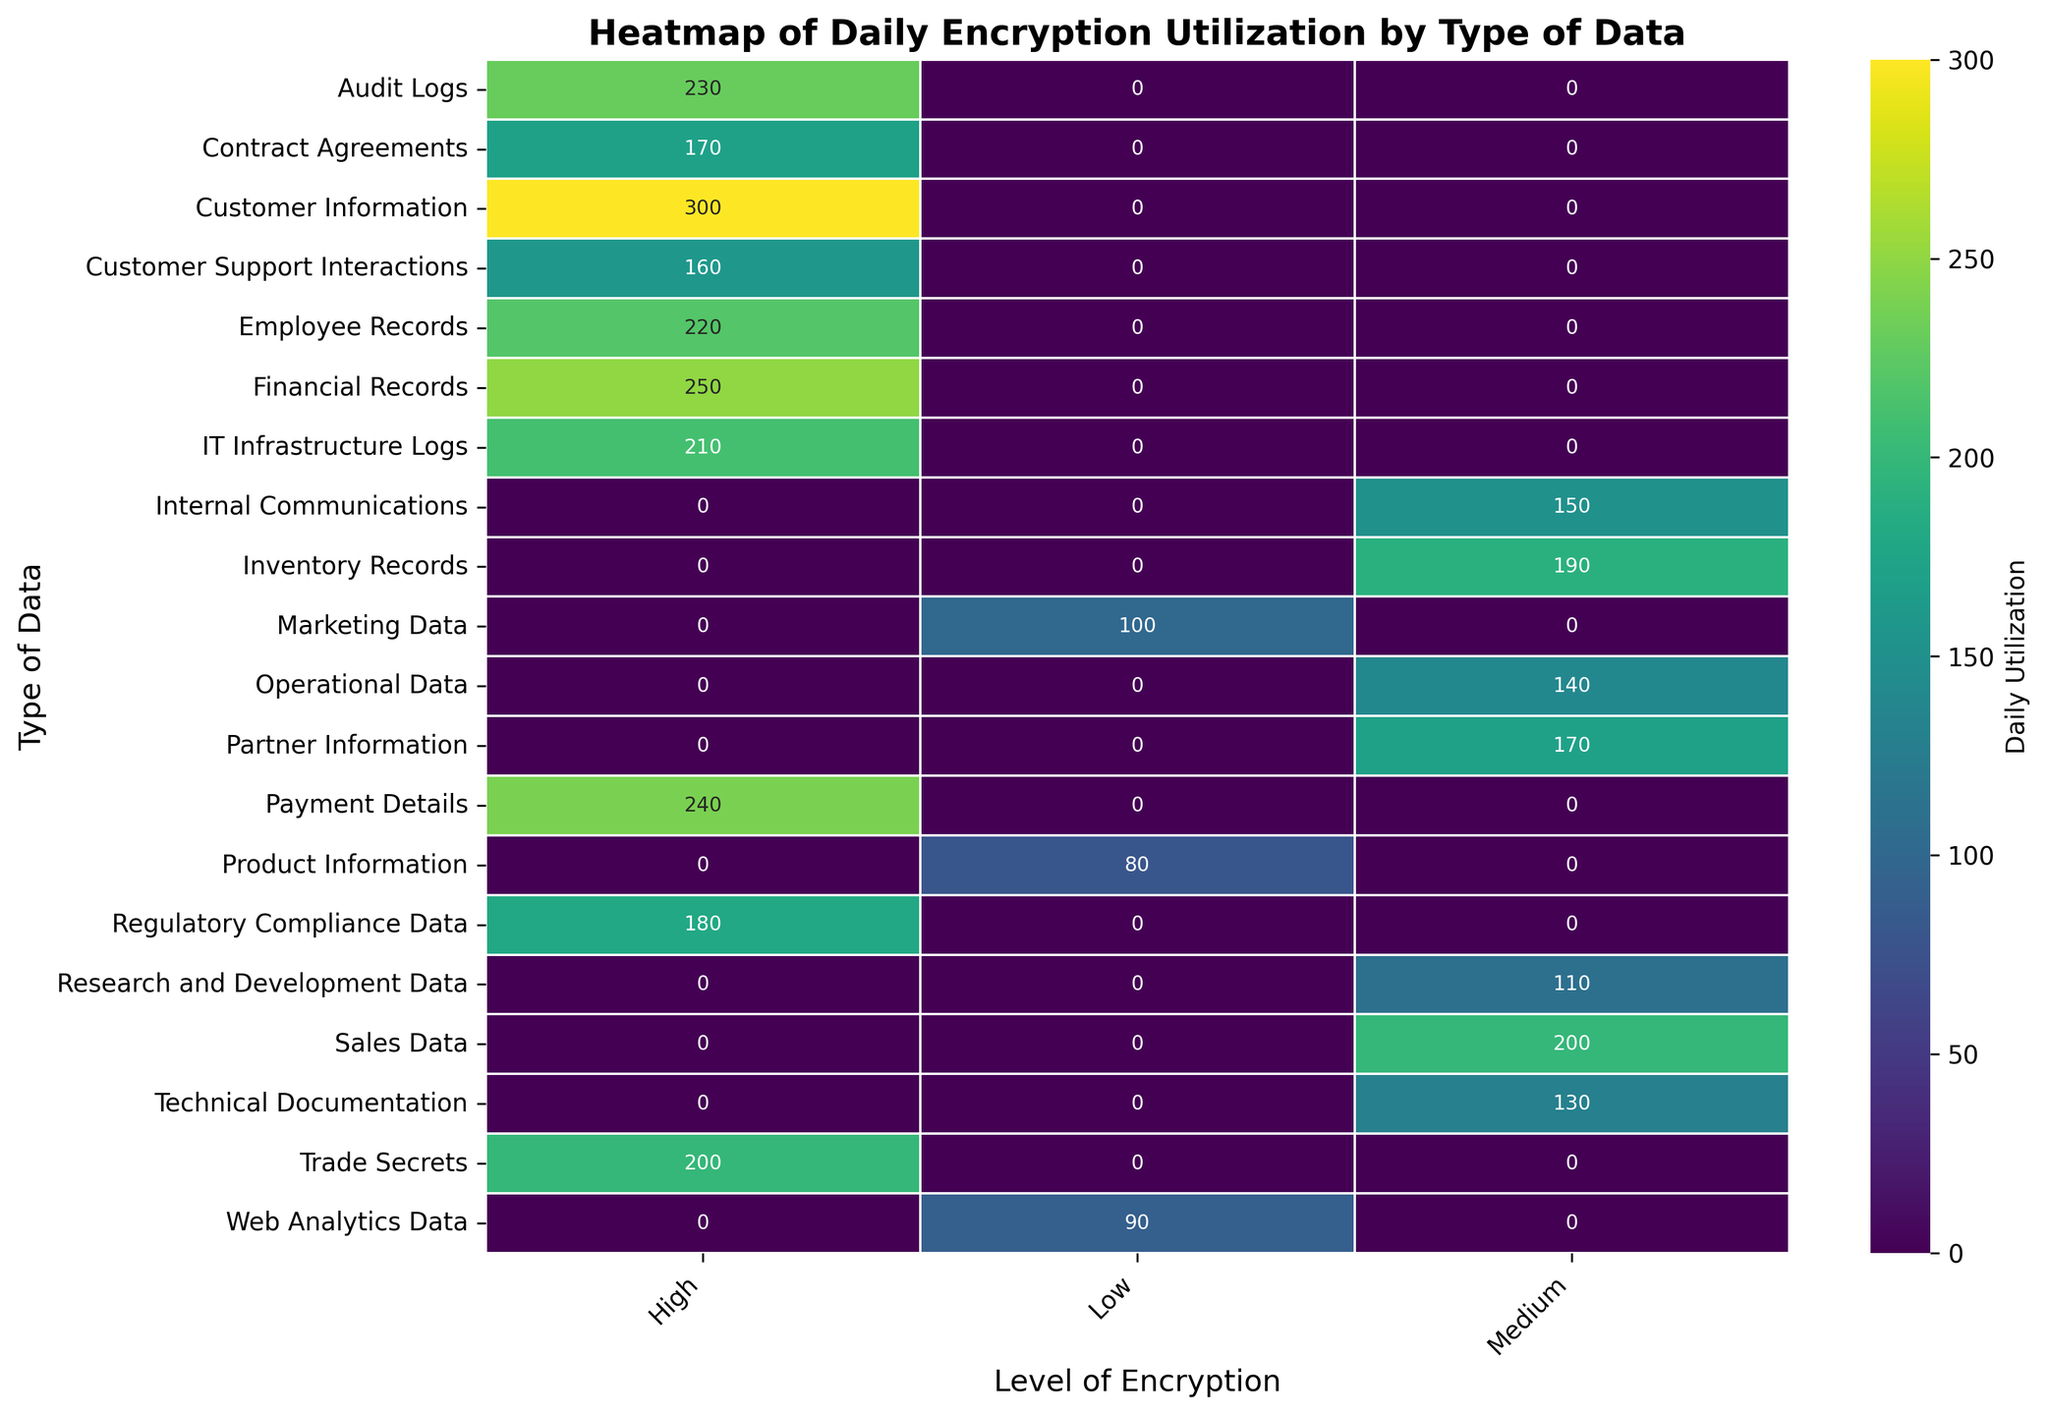What type of data has the highest daily utilization with a high level of encryption? First, filter for data types with a 'High' level of encryption. Then, compare their daily utilization values: Customer Information (300), Financial Records (250), Employee Records (220), Regulatory Compliance Data (180), Customer Support Interactions (160), IT Infrastructure Logs (210), Audit Logs (230), Payment Details (240), Contract Agreements (170), and Trade Secrets (200). Customer Information has the highest utilization at 300.
Answer: Customer Information Which type of data has the lowest daily utilization with a low level of encryption? First, identify the data types with a 'Low' level of encryption: Marketing Data (100), Product Information (80), and Web Analytics Data (90). Compare their daily utilizations and find that Product Information has the lowest at 80.
Answer: Product Information What is the average daily utilization of data types with a medium level of encryption? First, identify the data types with a 'Medium' level of encryption: Internal Communications (150), Sales Data (200), Technical Documentation (130), Partner Information (170), R&D Data (110), Operational Data (140), Inventory Records (190). Sum these utilizations: 150 + 200 + 130 + 170 + 110 + 140 + 190 = 1090. There are 7 data types, so divide 1090 by 7: 1090 / 7 ≈ 155.71
Answer: ~155.71 Compare the daily utilizations of Financial Records and Payment Details. Which one is higher? Inspect the daily utilization values for both Financial Records and Payment Details: Financial Records (250) and Payment Details (240). Since 250 > 240, Financial Records has higher daily utilization.
Answer: Financial Records Is the average daily utilization of data types with high levels of encryption higher than those with medium levels of encryption? First, calculate the average daily utilization for data types with a 'High' level of encryption: (300 + 250 + 220 + 180 + 210 + 230 + 240 + 170 + 200) / 9 = 2000 / 9 ≈ 222.22. For 'Medium' level: (150 + 200 + 130 + 170 + 110 + 140 + 190) / 7 = 1090 / 7 ≈ 155.71. Compare the averages: 222.22 > 155.71, so the average for high encryption is higher.
Answer: Yes Which type of data with a medium level of encryption has the highest daily utilization? Identify the data types with 'Medium' encryption and their daily utilizations: Internal Communications (150), Sales Data (200), Technical Documentation (130), Partner Information (170), R&D Data (110), Operational Data (140), Inventory Records (190). Compare them and find that Sales Data has the highest utilization at 200.
Answer: Sales Data What is the difference in daily utilization between the highest and lowest utilized data types in the dataset? Identify the highest and lowest daily utilizations: Customer Information (300) and Product Information (80). Calculate the difference: 300 - 80 = 220.
Answer: 220 Does 'Internal Communications' have higher or lower daily utilization than 'Customer Support Interactions'? Compare their daily utilization values: Internal Communications (150) and Customer Support Interactions (160). Since 150 < 160, Internal Communications has lower daily utilization.
Answer: Lower Which data types have a daily utilization of exactly 200? Identify data types with exactly 200 daily utilization: Sales Data and Trade Secrets.
Answer: Sales Data and Trade Secrets Among data types encrypted at a high level, which two have the closest daily utilization, and what is their difference? Identify the daily utilizations: Customer Information (300), Financial Records (250), Employee Records (220), Regulatory Compliance Data (180), Customer Support Interactions (160), IT Infrastructure Logs (210), Audit Logs (230), Payment Details (240), Contract Agreements (170), Trade Secrets (200). The closest pair is Financial Records (250) and Payment Details (240). Calculate the difference: 250 - 240 = 10.
Answer: Financial Records and Payment Details, 10 